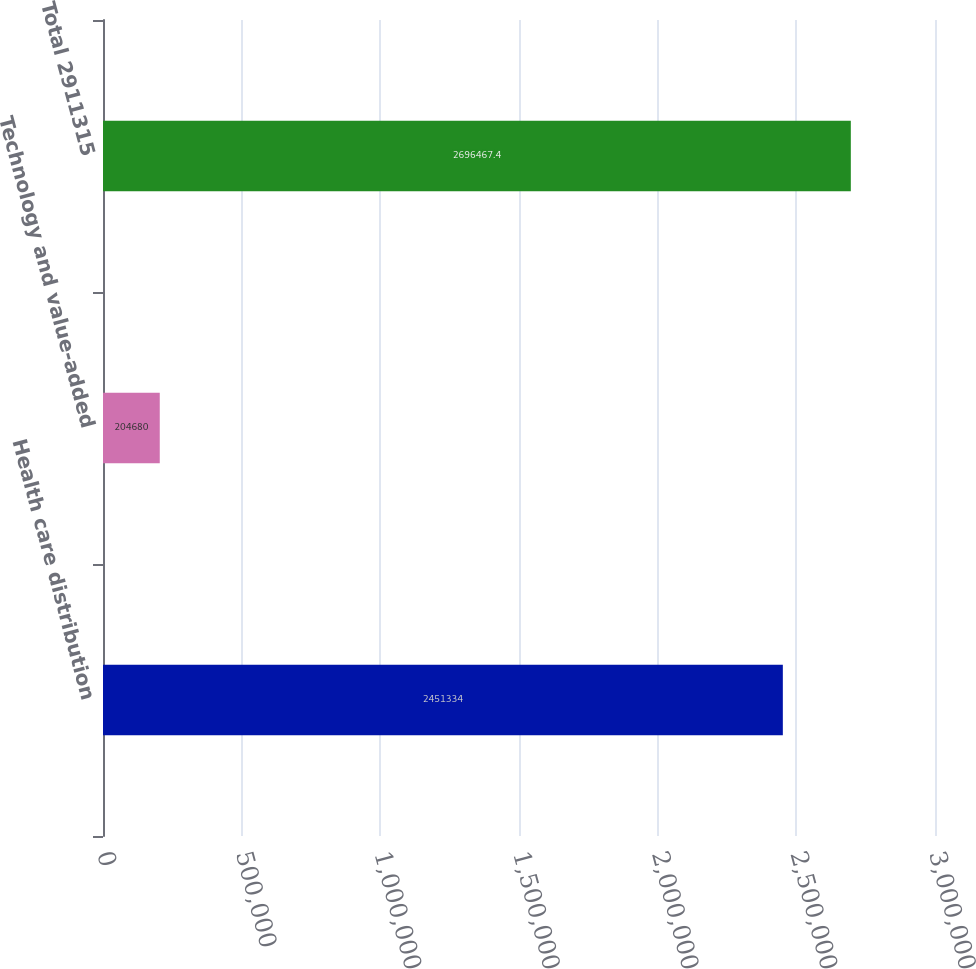<chart> <loc_0><loc_0><loc_500><loc_500><bar_chart><fcel>Health care distribution<fcel>Technology and value-added<fcel>Total 2911315<nl><fcel>2.45133e+06<fcel>204680<fcel>2.69647e+06<nl></chart> 